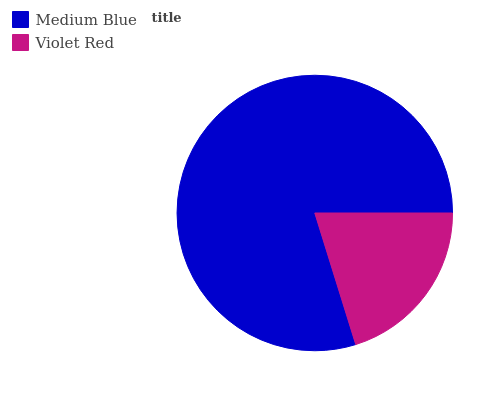Is Violet Red the minimum?
Answer yes or no. Yes. Is Medium Blue the maximum?
Answer yes or no. Yes. Is Violet Red the maximum?
Answer yes or no. No. Is Medium Blue greater than Violet Red?
Answer yes or no. Yes. Is Violet Red less than Medium Blue?
Answer yes or no. Yes. Is Violet Red greater than Medium Blue?
Answer yes or no. No. Is Medium Blue less than Violet Red?
Answer yes or no. No. Is Medium Blue the high median?
Answer yes or no. Yes. Is Violet Red the low median?
Answer yes or no. Yes. Is Violet Red the high median?
Answer yes or no. No. Is Medium Blue the low median?
Answer yes or no. No. 